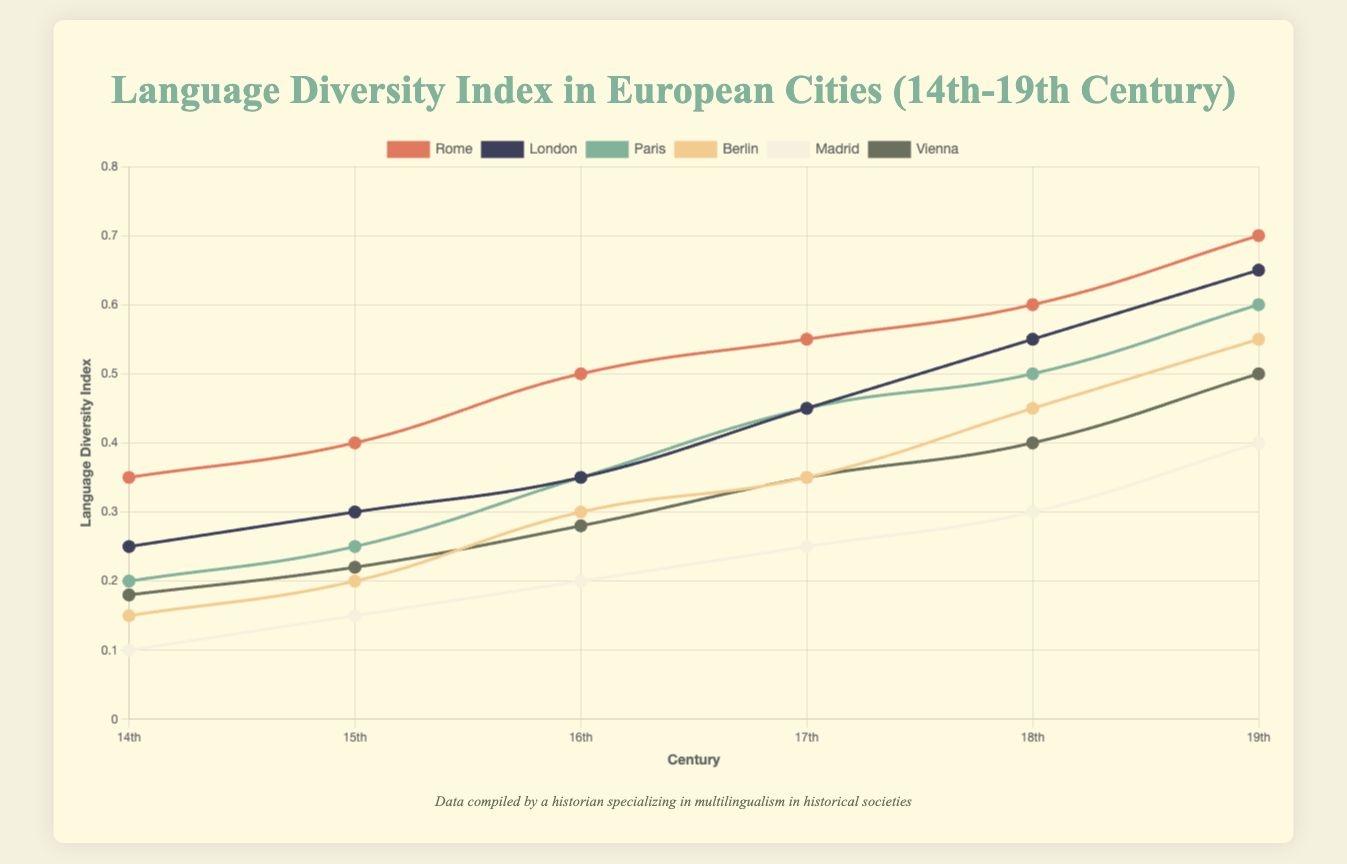Which city had the highest Language Diversity Index in the 19th century? Look at the data points corresponding to each city in the 19th century and identify the highest value. Rome has the highest value at 0.70.
Answer: Rome What is the difference in Language Diversity Index between Berlin and Madrid in the 17th century? Find the index values for both cities in the 17th century (Berlin: 0.35, Madrid: 0.25). Subtract Madrid's value from Berlin's value: 0.35 - 0.25 = 0.10.
Answer: 0.10 Which city showed the most significant increase in Language Diversity Index between the 14th and 19th centuries? Calculate the difference between the 19th and 14th-century values for each city. Rome has the largest increase, from 0.35 to 0.70, which is 0.35.
Answer: Rome How does the 16th-century Language Diversity Index for Paris compare with that of Vienna? Compare the index values for Paris and Vienna in the 16th century (Paris: 0.35, Vienna: 0.28). Paris has a higher index.
Answer: Paris Which century shows the most considerable increase in Language Diversity Index for London? Analyze the differences between London’s index values in consecutive centuries. The 15th to 16th century shows the least increase (0.05), but the highest increase is from the 16th to the 17th century (0.10).
Answer: 17th century On average, how does the Language Diversity Index of Madrid compare to the average index of Berlin across all centuries? Calculate the average index for Madrid (0.10, 0.15, 0.20, 0.25, 0.30, 0.40; sum = 1.40, average = 0.233) and Berlin (0.15, 0.20, 0.30, 0.35, 0.45, 0.55; sum = 2.00, average = 0.333). Berlin's average is higher.
Answer: Berlin What's the median Language Diversity Index for Vienna over the six centuries? List Vienna's indices (0.18, 0.22, 0.28, 0.35, 0.40, 0.50) in ascending order. The median (middle value) is the average of the third and fourth values (0.28, 0.35), which is (0.28 + 0.35) / 2 = 0.315.
Answer: 0.315 What is Rome's index value in the 18th century and how does it visually compare in height to Vienna's in the same century? Find Rome’s and Vienna’s values in the 18th century (Rome: 0.60, Vienna: 0.40). Rome’s index is higher. Visually, Rome's line will be higher on the y-axis than Vienna's in the 18th century.
Answer: Rome's is higher 